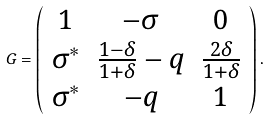<formula> <loc_0><loc_0><loc_500><loc_500>G = \left ( \begin{array} { c c c } 1 & - \sigma & 0 \\ \sigma ^ { * } & \frac { 1 - \delta } { 1 + \delta } - q & \frac { 2 \delta } { 1 + \delta } \\ \sigma ^ { * } & - q & 1 \end{array} \right ) .</formula> 